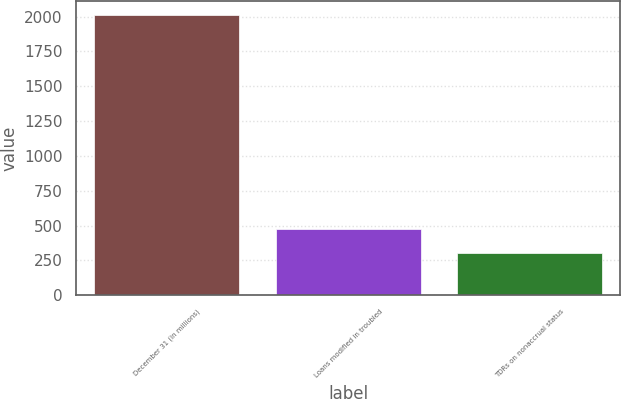Convert chart to OTSL. <chart><loc_0><loc_0><loc_500><loc_500><bar_chart><fcel>December 31 (in millions)<fcel>Loans modified in troubled<fcel>TDRs on nonaccrual status<nl><fcel>2014<fcel>476.8<fcel>306<nl></chart> 